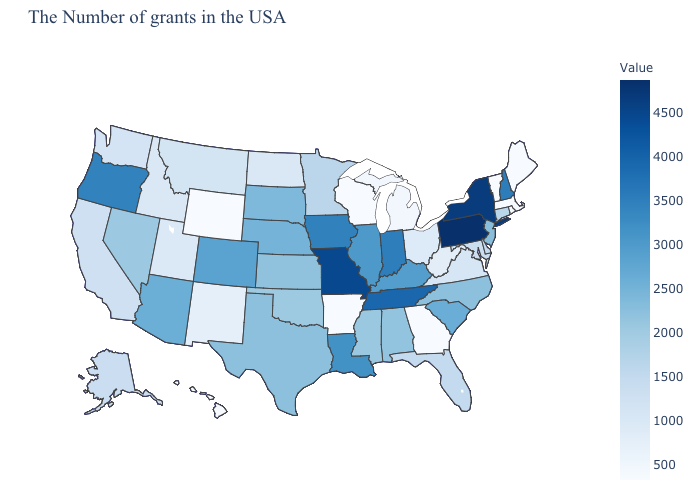Which states have the highest value in the USA?
Be succinct. Pennsylvania. Does Hawaii have the lowest value in the West?
Quick response, please. Yes. Does Pennsylvania have the highest value in the USA?
Short answer required. Yes. Which states have the lowest value in the USA?
Give a very brief answer. Maine, Massachusetts, Rhode Island, Vermont, Georgia, Wisconsin, Arkansas, Wyoming, Hawaii. 